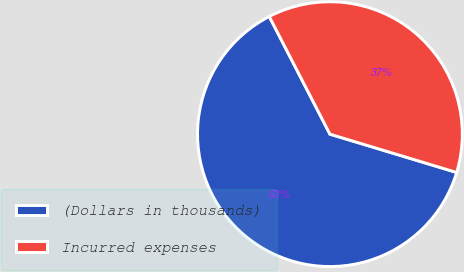Convert chart. <chart><loc_0><loc_0><loc_500><loc_500><pie_chart><fcel>(Dollars in thousands)<fcel>Incurred expenses<nl><fcel>62.75%<fcel>37.25%<nl></chart> 